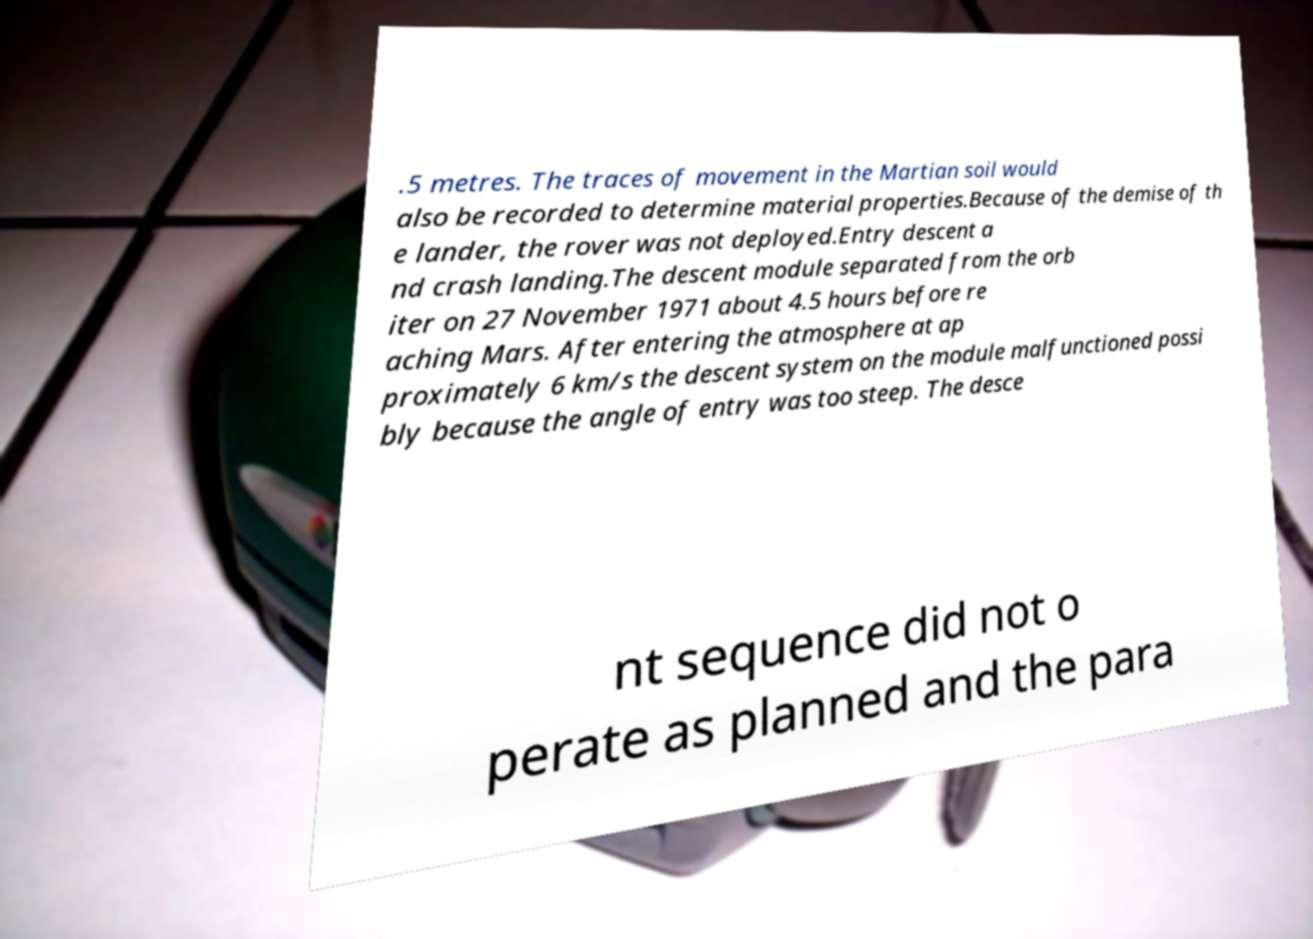For documentation purposes, I need the text within this image transcribed. Could you provide that? .5 metres. The traces of movement in the Martian soil would also be recorded to determine material properties.Because of the demise of th e lander, the rover was not deployed.Entry descent a nd crash landing.The descent module separated from the orb iter on 27 November 1971 about 4.5 hours before re aching Mars. After entering the atmosphere at ap proximately 6 km/s the descent system on the module malfunctioned possi bly because the angle of entry was too steep. The desce nt sequence did not o perate as planned and the para 